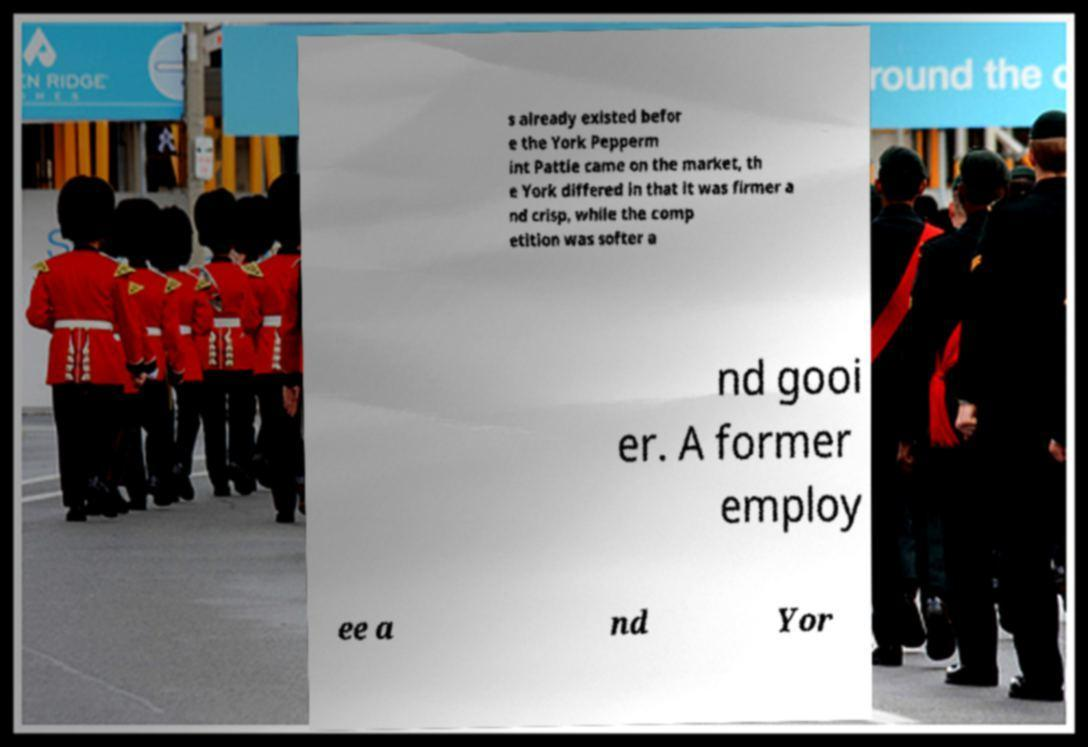For documentation purposes, I need the text within this image transcribed. Could you provide that? s already existed befor e the York Pepperm int Pattie came on the market, th e York differed in that it was firmer a nd crisp, while the comp etition was softer a nd gooi er. A former employ ee a nd Yor 